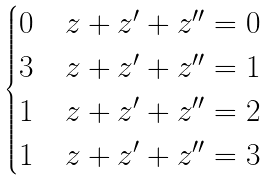Convert formula to latex. <formula><loc_0><loc_0><loc_500><loc_500>\begin{cases} 0 & z + z ^ { \prime } + z ^ { \prime \prime } = 0 \\ 3 & z + z ^ { \prime } + z ^ { \prime \prime } = 1 \\ 1 & z + z ^ { \prime } + z ^ { \prime \prime } = 2 \\ 1 & z + z ^ { \prime } + z ^ { \prime \prime } = 3 \end{cases}</formula> 